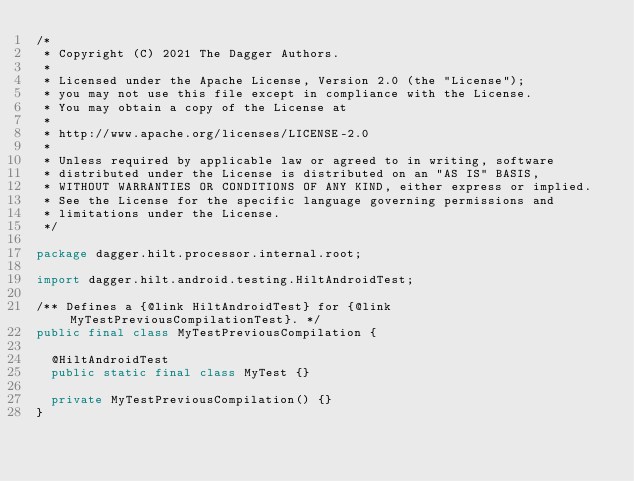Convert code to text. <code><loc_0><loc_0><loc_500><loc_500><_Java_>/*
 * Copyright (C) 2021 The Dagger Authors.
 *
 * Licensed under the Apache License, Version 2.0 (the "License");
 * you may not use this file except in compliance with the License.
 * You may obtain a copy of the License at
 *
 * http://www.apache.org/licenses/LICENSE-2.0
 *
 * Unless required by applicable law or agreed to in writing, software
 * distributed under the License is distributed on an "AS IS" BASIS,
 * WITHOUT WARRANTIES OR CONDITIONS OF ANY KIND, either express or implied.
 * See the License for the specific language governing permissions and
 * limitations under the License.
 */

package dagger.hilt.processor.internal.root;

import dagger.hilt.android.testing.HiltAndroidTest;

/** Defines a {@link HiltAndroidTest} for {@link MyTestPreviousCompilationTest}. */
public final class MyTestPreviousCompilation {

  @HiltAndroidTest
  public static final class MyTest {}

  private MyTestPreviousCompilation() {}
}
</code> 